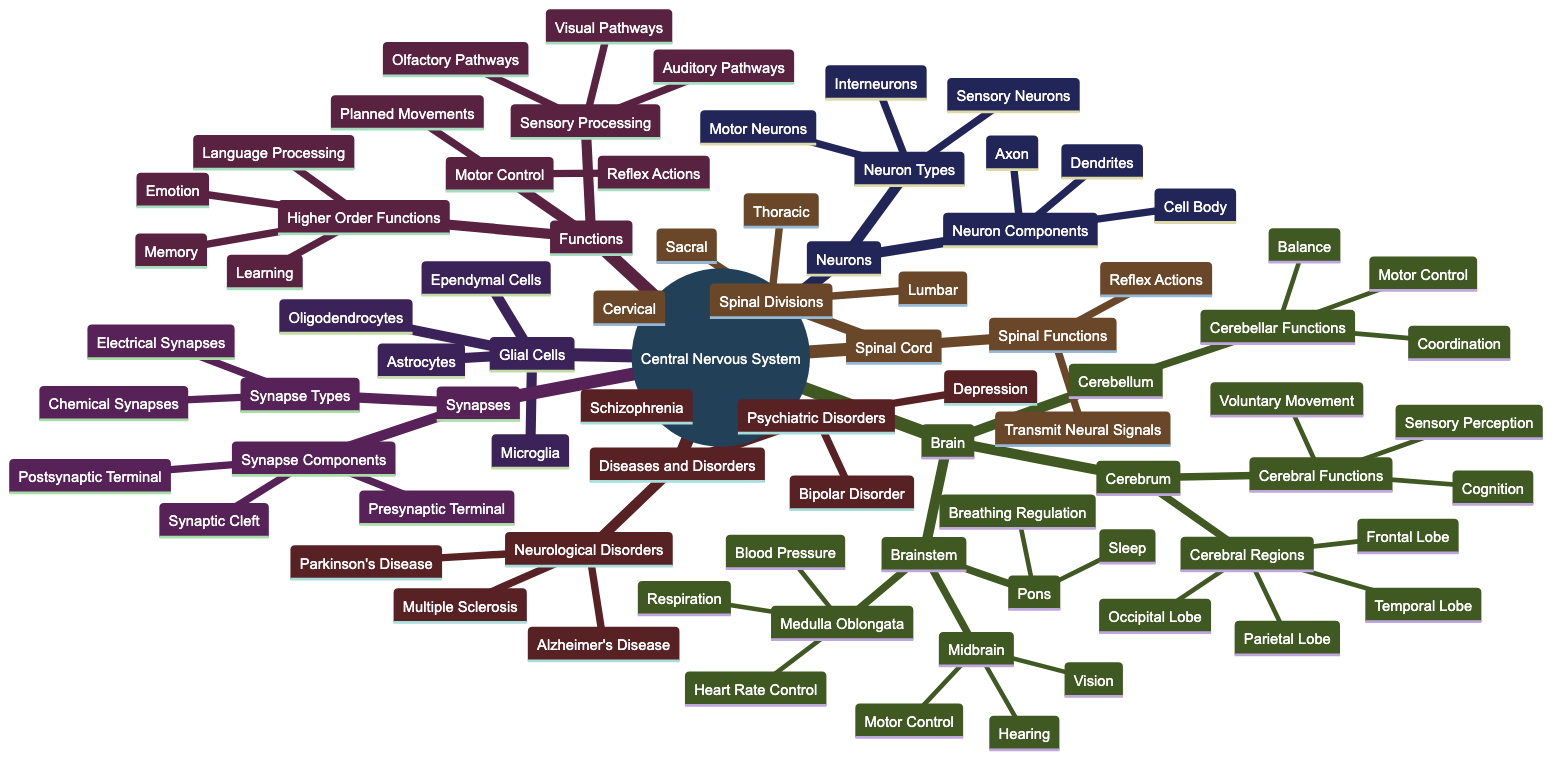What are the three main components of the Central Nervous System? The Central Nervous System is composed of the Brain, Spinal Cord, and Neurons. These components are shown as the first level of nodes connected to the root node "Central Nervous System."
Answer: Brain, Spinal Cord, Neurons Which lobe is responsible for sensory perception? The lobe associated with sensory perception is the Parietal Lobe, which is a subregion of the Cerebrum. The relationship is shown in the diagram where the Parietal Lobe is linked to the Cerebrum and its functions.
Answer: Parietal Lobe How many divisions are there in the Spinal Cord? The diagram lists four divisions of the Spinal Cord: Cervical, Thoracic, Lumbar, and Sacral. By counting the sub-nodes under Spinal Divisions, we find the total number.
Answer: 4 What functions are associated with the Medulla Oblongata? The Medulla Oblongata is associated with three primary functions: Heart Rate Control, Respiration, and Blood Pressure. These functions are illustrated as sub-nodes under Medulla Oblongata in the Brainstem section.
Answer: Heart Rate Control, Respiration, Blood Pressure What type of neurons are involved in reflex actions? Reflex actions involve Motor Neurons, as indicated in the Functions section where Motor Control includes Reflex Actions. The relationship indicates the role of Motor Neurons in executing these actions.
Answer: Motor Neurons Which types of synapses are identified in the diagram? The diagram identifies two types of synapses: Electrical Synapses and Chemical Synapses. These types are shown as first-level distinctions under the Synapses component of the diagram.
Answer: Electrical Synapses, Chemical Synapses Which disorders fall under the category of Neurological Disorders? The diagram lists three specific Neurological Disorders: Alzheimer's Disease, Parkinson's Disease, and Multiple Sclerosis. These are shown as sub-nodes under the Diseases and Disorders section.
Answer: Alzheimer's Disease, Parkinson's Disease, Multiple Sclerosis What glial cell type is shown as responsible for immune defense in the central nervous system? The type of glial cell responsible for immune defense is Microglia, which is explicit in the Glial Cells section of the diagram as one of the types listed.
Answer: Microglia What functions are included in Higher Order Functions? Higher Order Functions include Learning, Memory, Emotion, and Language Processing, as listed in the Functions section of the diagram, which breaks down these complex processes associated with brain function.
Answer: Learning, Memory, Emotion, Language Processing What is the primary role of the Cerebellum? The primary role of the Cerebellum is to facilitate Coordination, Balance, and Motor Control. These functions are noted directly under the Cerebellum node as part of the overall brain function.
Answer: Coordination, Balance, Motor Control 